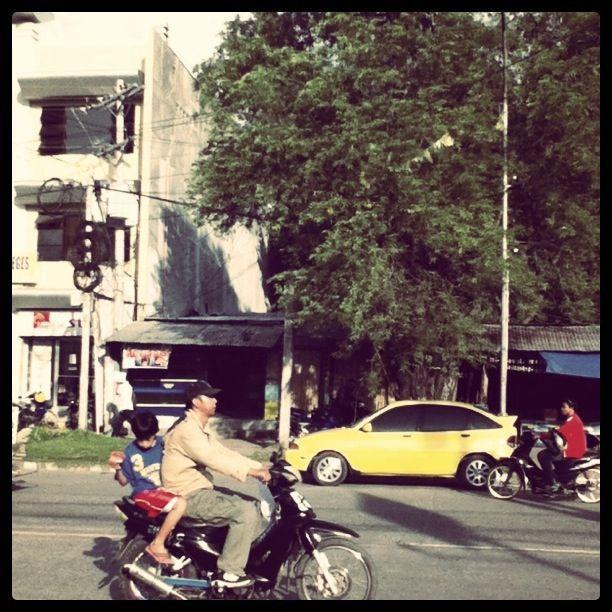Which mode of transportation shown here is most economical?
Select the accurate response from the four choices given to answer the question.
Options: Truck, semi, car, motor cycle. Motor cycle. 